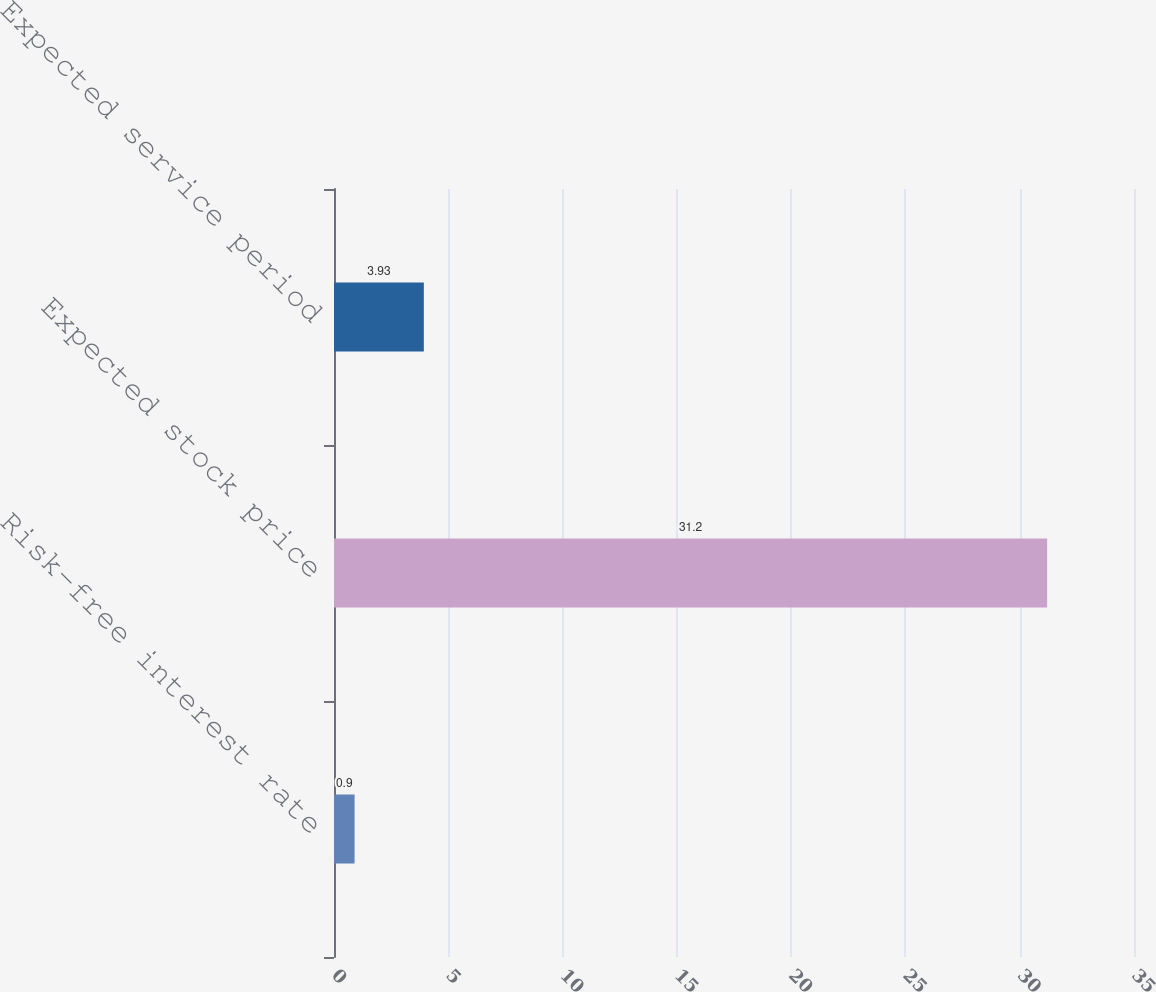Convert chart. <chart><loc_0><loc_0><loc_500><loc_500><bar_chart><fcel>Risk-free interest rate<fcel>Expected stock price<fcel>Expected service period<nl><fcel>0.9<fcel>31.2<fcel>3.93<nl></chart> 